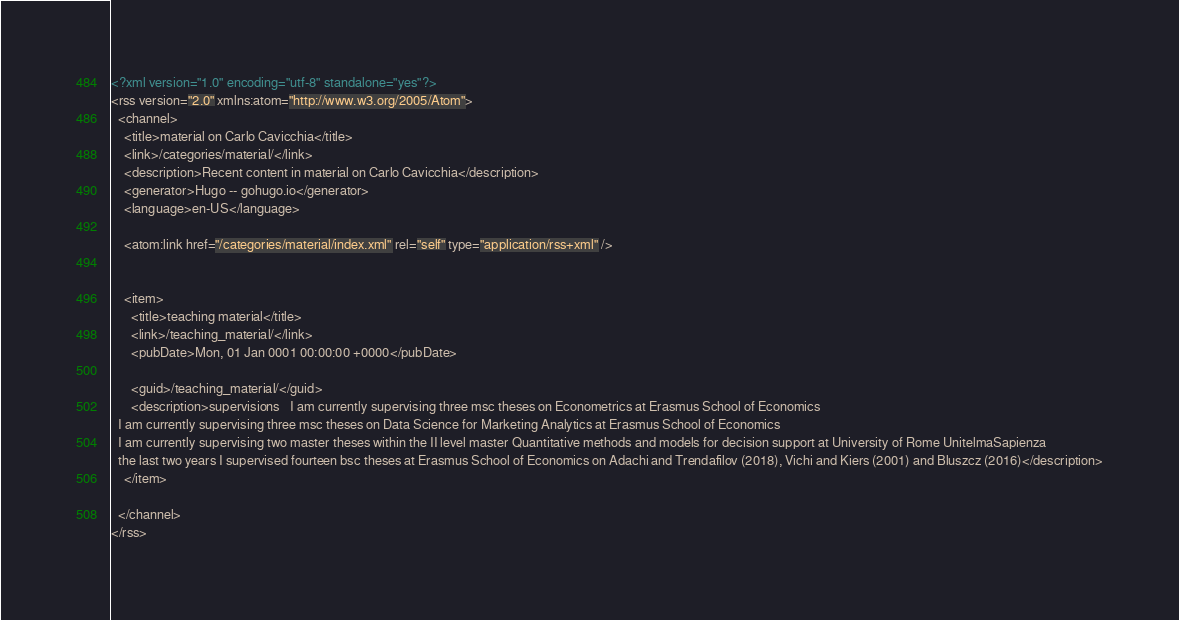<code> <loc_0><loc_0><loc_500><loc_500><_XML_><?xml version="1.0" encoding="utf-8" standalone="yes"?>
<rss version="2.0" xmlns:atom="http://www.w3.org/2005/Atom">
  <channel>
    <title>material on Carlo Cavicchia</title>
    <link>/categories/material/</link>
    <description>Recent content in material on Carlo Cavicchia</description>
    <generator>Hugo -- gohugo.io</generator>
    <language>en-US</language>
    
	<atom:link href="/categories/material/index.xml" rel="self" type="application/rss+xml" />
    
    
    <item>
      <title>teaching material</title>
      <link>/teaching_material/</link>
      <pubDate>Mon, 01 Jan 0001 00:00:00 +0000</pubDate>
      
      <guid>/teaching_material/</guid>
      <description>supervisions   I am currently supervising three msc theses on Econometrics at Erasmus School of Economics
  I am currently supervising three msc theses on Data Science for Marketing Analytics at Erasmus School of Economics
  I am currently supervising two master theses within the II level master Quantitative methods and models for decision support at University of Rome UnitelmaSapienza
  the last two years I supervised fourteen bsc theses at Erasmus School of Economics on Adachi and Trendafilov (2018), Vichi and Kiers (2001) and Bluszcz (2016)</description>
    </item>
    
  </channel>
</rss></code> 